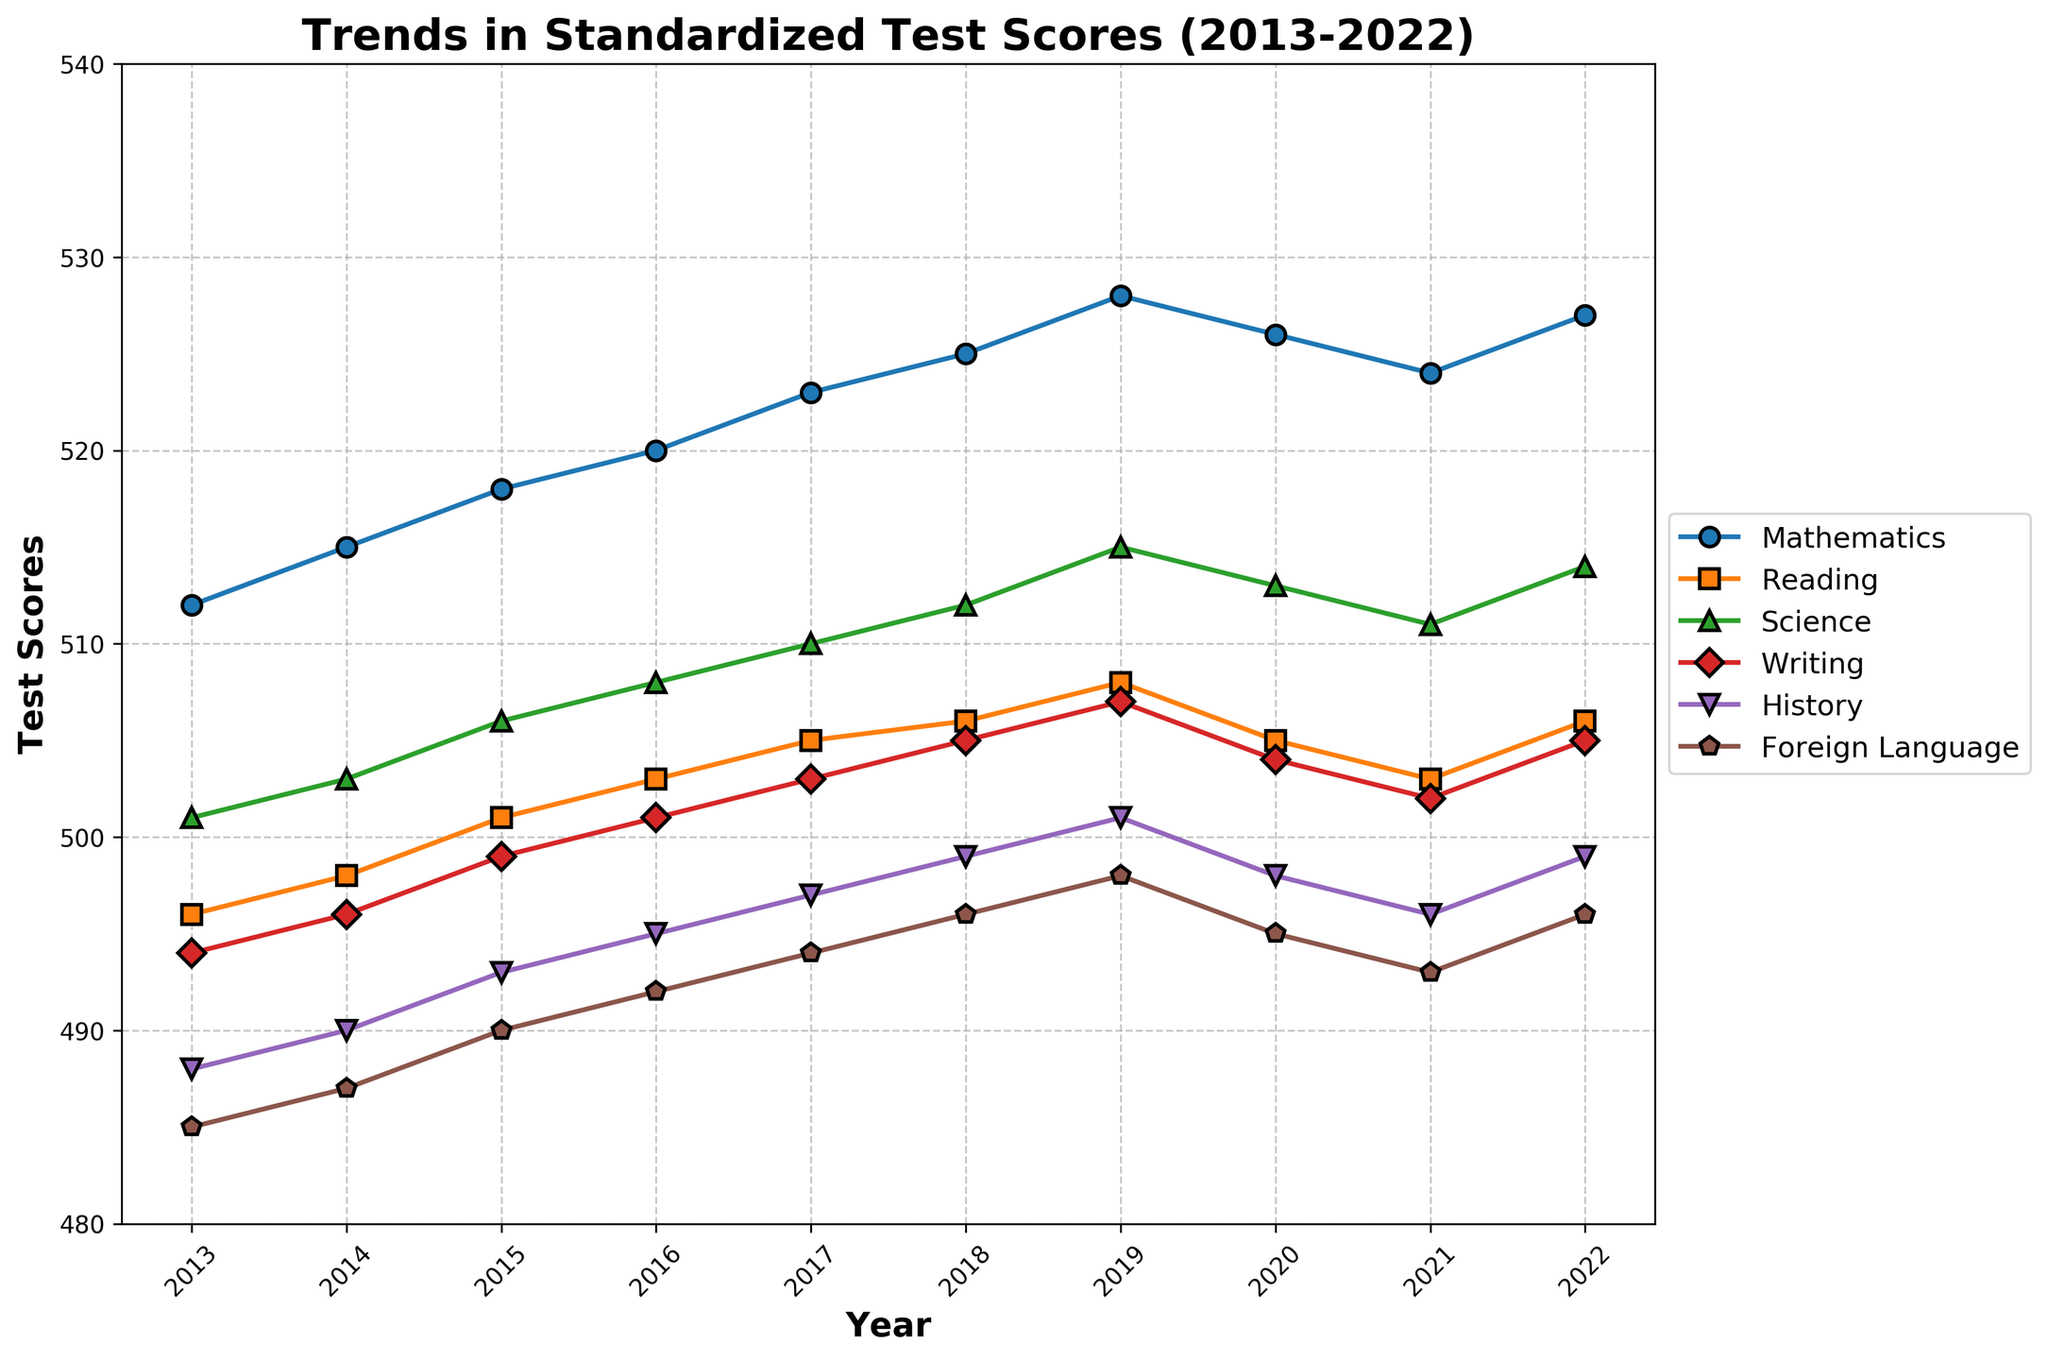What subject showed the most significant improvement in scores over the entire period from 2013 to 2022? To find which subject showed the most significant improvement, subtract the 2013 score from the 2022 score for each subject. Compare the differences: Mathematics (527-512=15), Reading (506-496=10), Science (514-501=13), Writing (505-494=11), History (499-488=11), Foreign Language (496-485=11). The highest improvement is in Mathematics with an increase of 15 points.
Answer: Mathematics Which subject had the lowest score in any single year shown? Reviewing the chart for the lowest single point value across all subjects, Foreign Language had the lowest score in 2013 with a score of 485.
Answer: Foreign Language What was the difference in Mathematics scores between 2017 and 2020? To find the difference in scores, subtract the 2017 score from the 2020 score: 526 - 523 = 3. Therefore, the difference is 3 points.
Answer: 3 Between 2013 and 2022, did any subject experience a decline in scores? By examining the trend lines for each subject, we see that all subjects have upward trends from 2013 to 2022, with no overall decline in the scores.
Answer: No Which year showed the highest average score across all subjects? To find the highest average score, calculate the average for each year. For 2022: (527 + 506 + 514 + 505 + 499 + 496) / 6 = 507.83. Similarly, compute for each year and compare them. The highest average score is 507.83 in 2022.
Answer: 2022 How much did the Reading scores increase on average per year from 2013 to 2022? First, calculate the total increase in Reading scores from 2013 to 2022: 506 - 496 = 10 points. Divide this by the number of years (2022-2013 = 9 years): 10 / 9 ≈ 1.11. Therefore, the average annual increase is approximately 1.11 points.
Answer: 1.11 Which subject had the closest final scores in 2022? Compare the final scores in 2022 for each subject to find the smallest difference: Mathematics 527, Reading 506, Science 514, Writing 505, History 499, Foreign Language 496. The closest final scores are Writing (505) and Reading (506), with a difference of 1 point.
Answer: Writing and Reading 